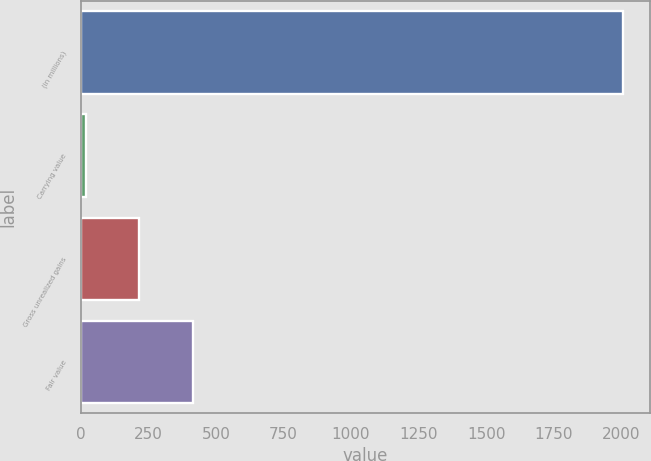Convert chart. <chart><loc_0><loc_0><loc_500><loc_500><bar_chart><fcel>(in millions)<fcel>Carrying value<fcel>Gross unrealized gains<fcel>Fair value<nl><fcel>2007<fcel>18<fcel>216.9<fcel>415.8<nl></chart> 